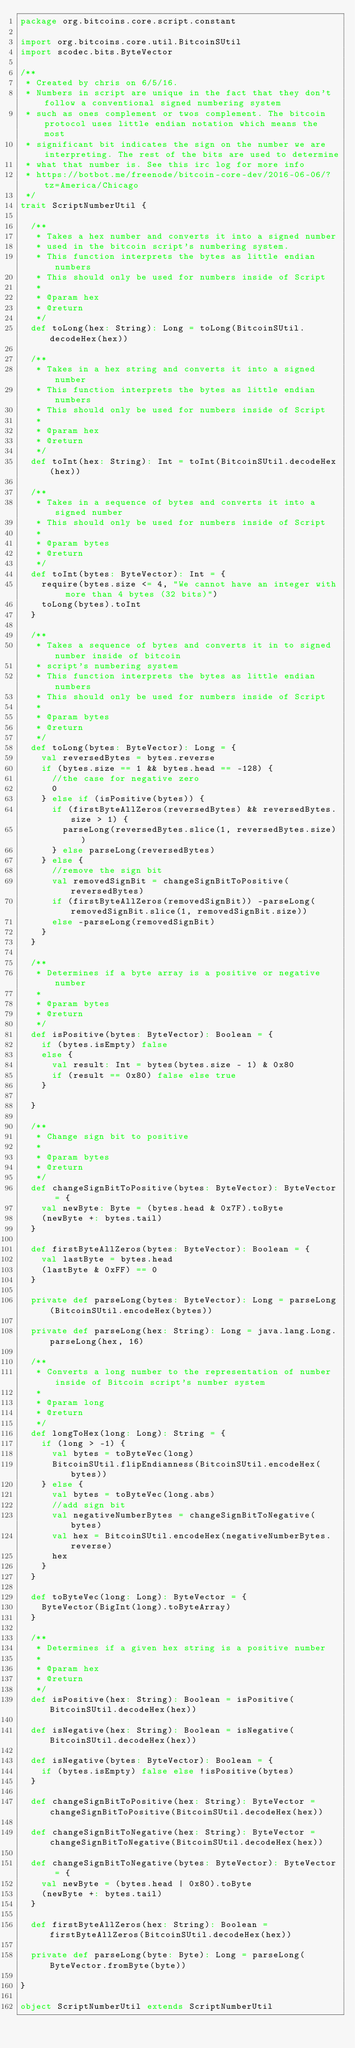<code> <loc_0><loc_0><loc_500><loc_500><_Scala_>package org.bitcoins.core.script.constant

import org.bitcoins.core.util.BitcoinSUtil
import scodec.bits.ByteVector

/**
 * Created by chris on 6/5/16.
 * Numbers in script are unique in the fact that they don't follow a conventional signed numbering system
 * such as ones complement or twos complement. The bitcoin protocol uses little endian notation which means the most
 * significant bit indicates the sign on the number we are interpreting. The rest of the bits are used to determine
 * what that number is. See this irc log for more info
 * https://botbot.me/freenode/bitcoin-core-dev/2016-06-06/?tz=America/Chicago
 */
trait ScriptNumberUtil {

  /**
   * Takes a hex number and converts it into a signed number
   * used in the bitcoin script's numbering system.
   * This function interprets the bytes as little endian numbers
   * This should only be used for numbers inside of Script
   *
   * @param hex
   * @return
   */
  def toLong(hex: String): Long = toLong(BitcoinSUtil.decodeHex(hex))

  /**
   * Takes in a hex string and converts it into a signed number
   * This function interprets the bytes as little endian numbers
   * This should only be used for numbers inside of Script
   *
   * @param hex
   * @return
   */
  def toInt(hex: String): Int = toInt(BitcoinSUtil.decodeHex(hex))

  /**
   * Takes in a sequence of bytes and converts it into a signed number
   * This should only be used for numbers inside of Script
   *
   * @param bytes
   * @return
   */
  def toInt(bytes: ByteVector): Int = {
    require(bytes.size <= 4, "We cannot have an integer with more than 4 bytes (32 bits)")
    toLong(bytes).toInt
  }

  /**
   * Takes a sequence of bytes and converts it in to signed number inside of bitcoin
   * script's numbering system
   * This function interprets the bytes as little endian numbers
   * This should only be used for numbers inside of Script
   *
   * @param bytes
   * @return
   */
  def toLong(bytes: ByteVector): Long = {
    val reversedBytes = bytes.reverse
    if (bytes.size == 1 && bytes.head == -128) {
      //the case for negative zero
      0
    } else if (isPositive(bytes)) {
      if (firstByteAllZeros(reversedBytes) && reversedBytes.size > 1) {
        parseLong(reversedBytes.slice(1, reversedBytes.size))
      } else parseLong(reversedBytes)
    } else {
      //remove the sign bit
      val removedSignBit = changeSignBitToPositive(reversedBytes)
      if (firstByteAllZeros(removedSignBit)) -parseLong(removedSignBit.slice(1, removedSignBit.size))
      else -parseLong(removedSignBit)
    }
  }

  /**
   * Determines if a byte array is a positive or negative number
   *
   * @param bytes
   * @return
   */
  def isPositive(bytes: ByteVector): Boolean = {
    if (bytes.isEmpty) false
    else {
      val result: Int = bytes(bytes.size - 1) & 0x80
      if (result == 0x80) false else true
    }

  }

  /**
   * Change sign bit to positive
   *
   * @param bytes
   * @return
   */
  def changeSignBitToPositive(bytes: ByteVector): ByteVector = {
    val newByte: Byte = (bytes.head & 0x7F).toByte
    (newByte +: bytes.tail)
  }

  def firstByteAllZeros(bytes: ByteVector): Boolean = {
    val lastByte = bytes.head
    (lastByte & 0xFF) == 0
  }

  private def parseLong(bytes: ByteVector): Long = parseLong(BitcoinSUtil.encodeHex(bytes))

  private def parseLong(hex: String): Long = java.lang.Long.parseLong(hex, 16)

  /**
   * Converts a long number to the representation of number inside of Bitcoin script's number system
   *
   * @param long
   * @return
   */
  def longToHex(long: Long): String = {
    if (long > -1) {
      val bytes = toByteVec(long)
      BitcoinSUtil.flipEndianness(BitcoinSUtil.encodeHex(bytes))
    } else {
      val bytes = toByteVec(long.abs)
      //add sign bit
      val negativeNumberBytes = changeSignBitToNegative(bytes)
      val hex = BitcoinSUtil.encodeHex(negativeNumberBytes.reverse)
      hex
    }
  }

  def toByteVec(long: Long): ByteVector = {
    ByteVector(BigInt(long).toByteArray)
  }

  /**
   * Determines if a given hex string is a positive number
   *
   * @param hex
   * @return
   */
  def isPositive(hex: String): Boolean = isPositive(BitcoinSUtil.decodeHex(hex))

  def isNegative(hex: String): Boolean = isNegative(BitcoinSUtil.decodeHex(hex))

  def isNegative(bytes: ByteVector): Boolean = {
    if (bytes.isEmpty) false else !isPositive(bytes)
  }

  def changeSignBitToPositive(hex: String): ByteVector = changeSignBitToPositive(BitcoinSUtil.decodeHex(hex))

  def changeSignBitToNegative(hex: String): ByteVector = changeSignBitToNegative(BitcoinSUtil.decodeHex(hex))

  def changeSignBitToNegative(bytes: ByteVector): ByteVector = {
    val newByte = (bytes.head | 0x80).toByte
    (newByte +: bytes.tail)
  }

  def firstByteAllZeros(hex: String): Boolean = firstByteAllZeros(BitcoinSUtil.decodeHex(hex))

  private def parseLong(byte: Byte): Long = parseLong(ByteVector.fromByte(byte))

}

object ScriptNumberUtil extends ScriptNumberUtil
</code> 